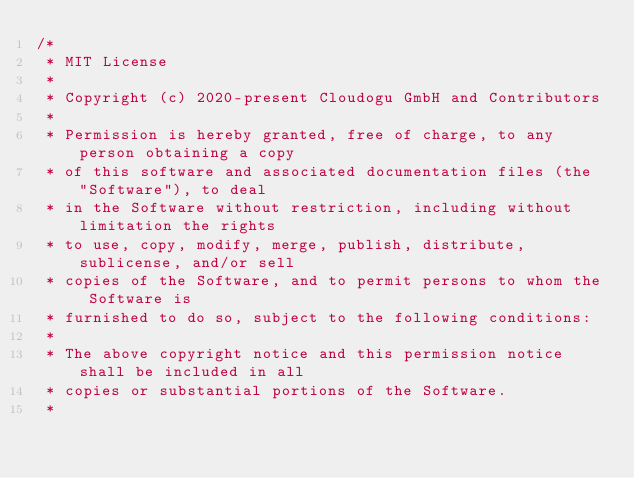Convert code to text. <code><loc_0><loc_0><loc_500><loc_500><_Java_>/*
 * MIT License
 *
 * Copyright (c) 2020-present Cloudogu GmbH and Contributors
 *
 * Permission is hereby granted, free of charge, to any person obtaining a copy
 * of this software and associated documentation files (the "Software"), to deal
 * in the Software without restriction, including without limitation the rights
 * to use, copy, modify, merge, publish, distribute, sublicense, and/or sell
 * copies of the Software, and to permit persons to whom the Software is
 * furnished to do so, subject to the following conditions:
 *
 * The above copyright notice and this permission notice shall be included in all
 * copies or substantial portions of the Software.
 *</code> 